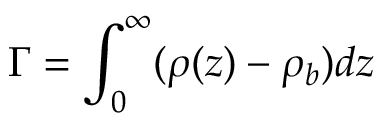<formula> <loc_0><loc_0><loc_500><loc_500>\Gamma = \int _ { 0 } ^ { \infty } ( \rho ( z ) - \rho _ { b } ) d z</formula> 